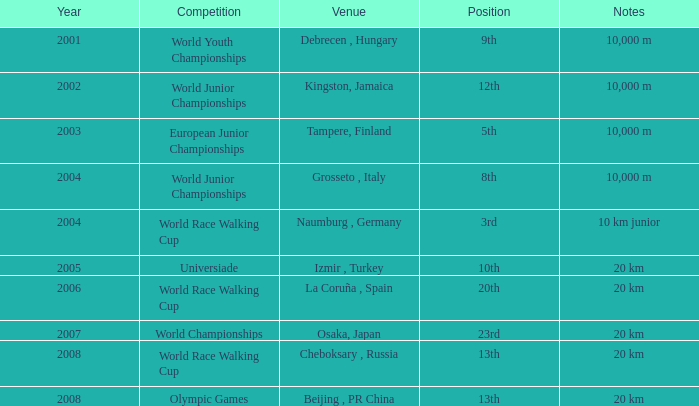What were the notes when his position was 10th? 20 km. 